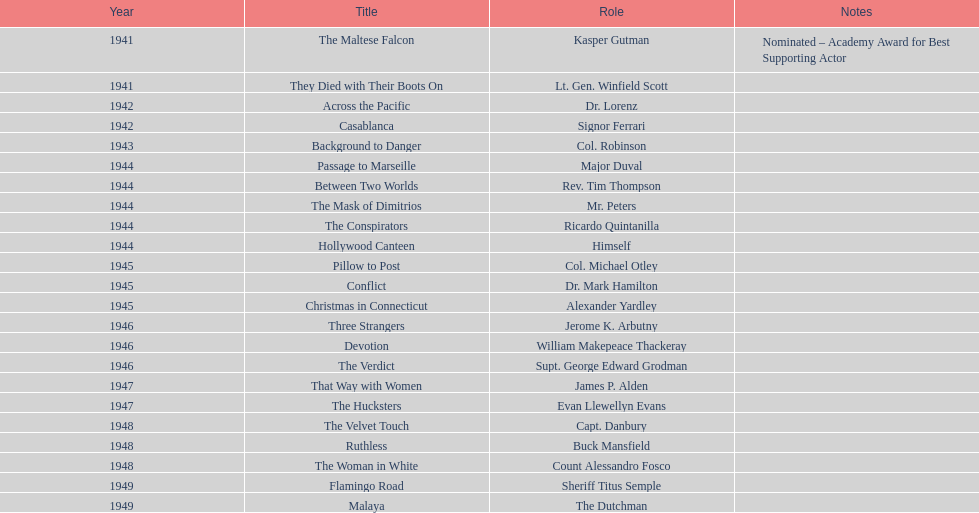What motion pictures did greenstreet perform in for 1946? Three Strangers, Devotion, The Verdict. 